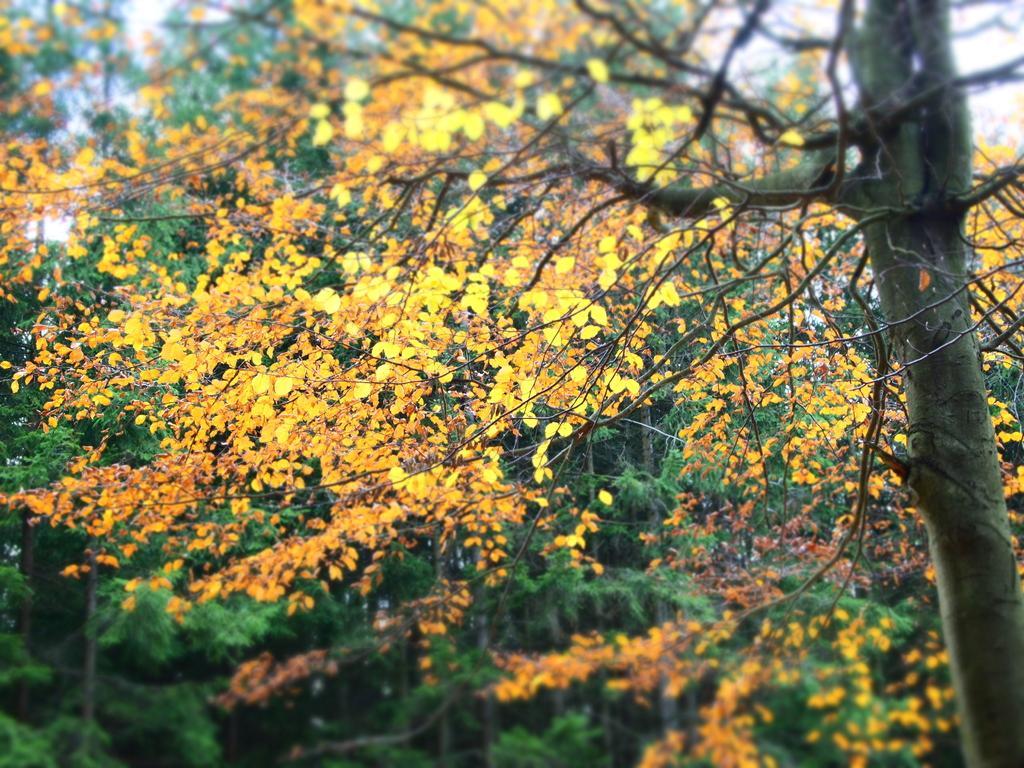Can you describe this image briefly? In the center of the image we can see the sky,trees etc. 